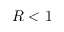<formula> <loc_0><loc_0><loc_500><loc_500>R < 1</formula> 